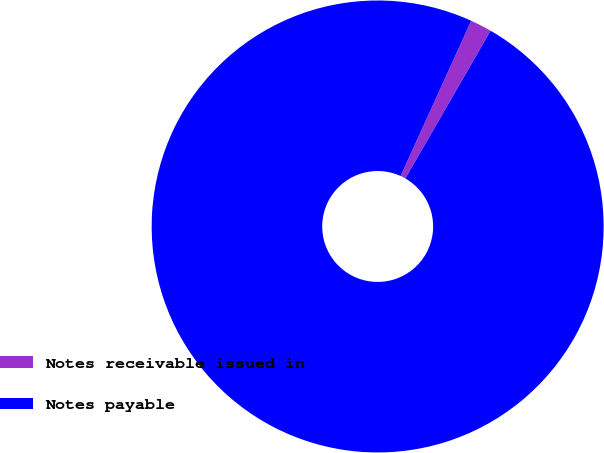<chart> <loc_0><loc_0><loc_500><loc_500><pie_chart><fcel>Notes receivable issued in<fcel>Notes payable<nl><fcel>1.54%<fcel>98.46%<nl></chart> 